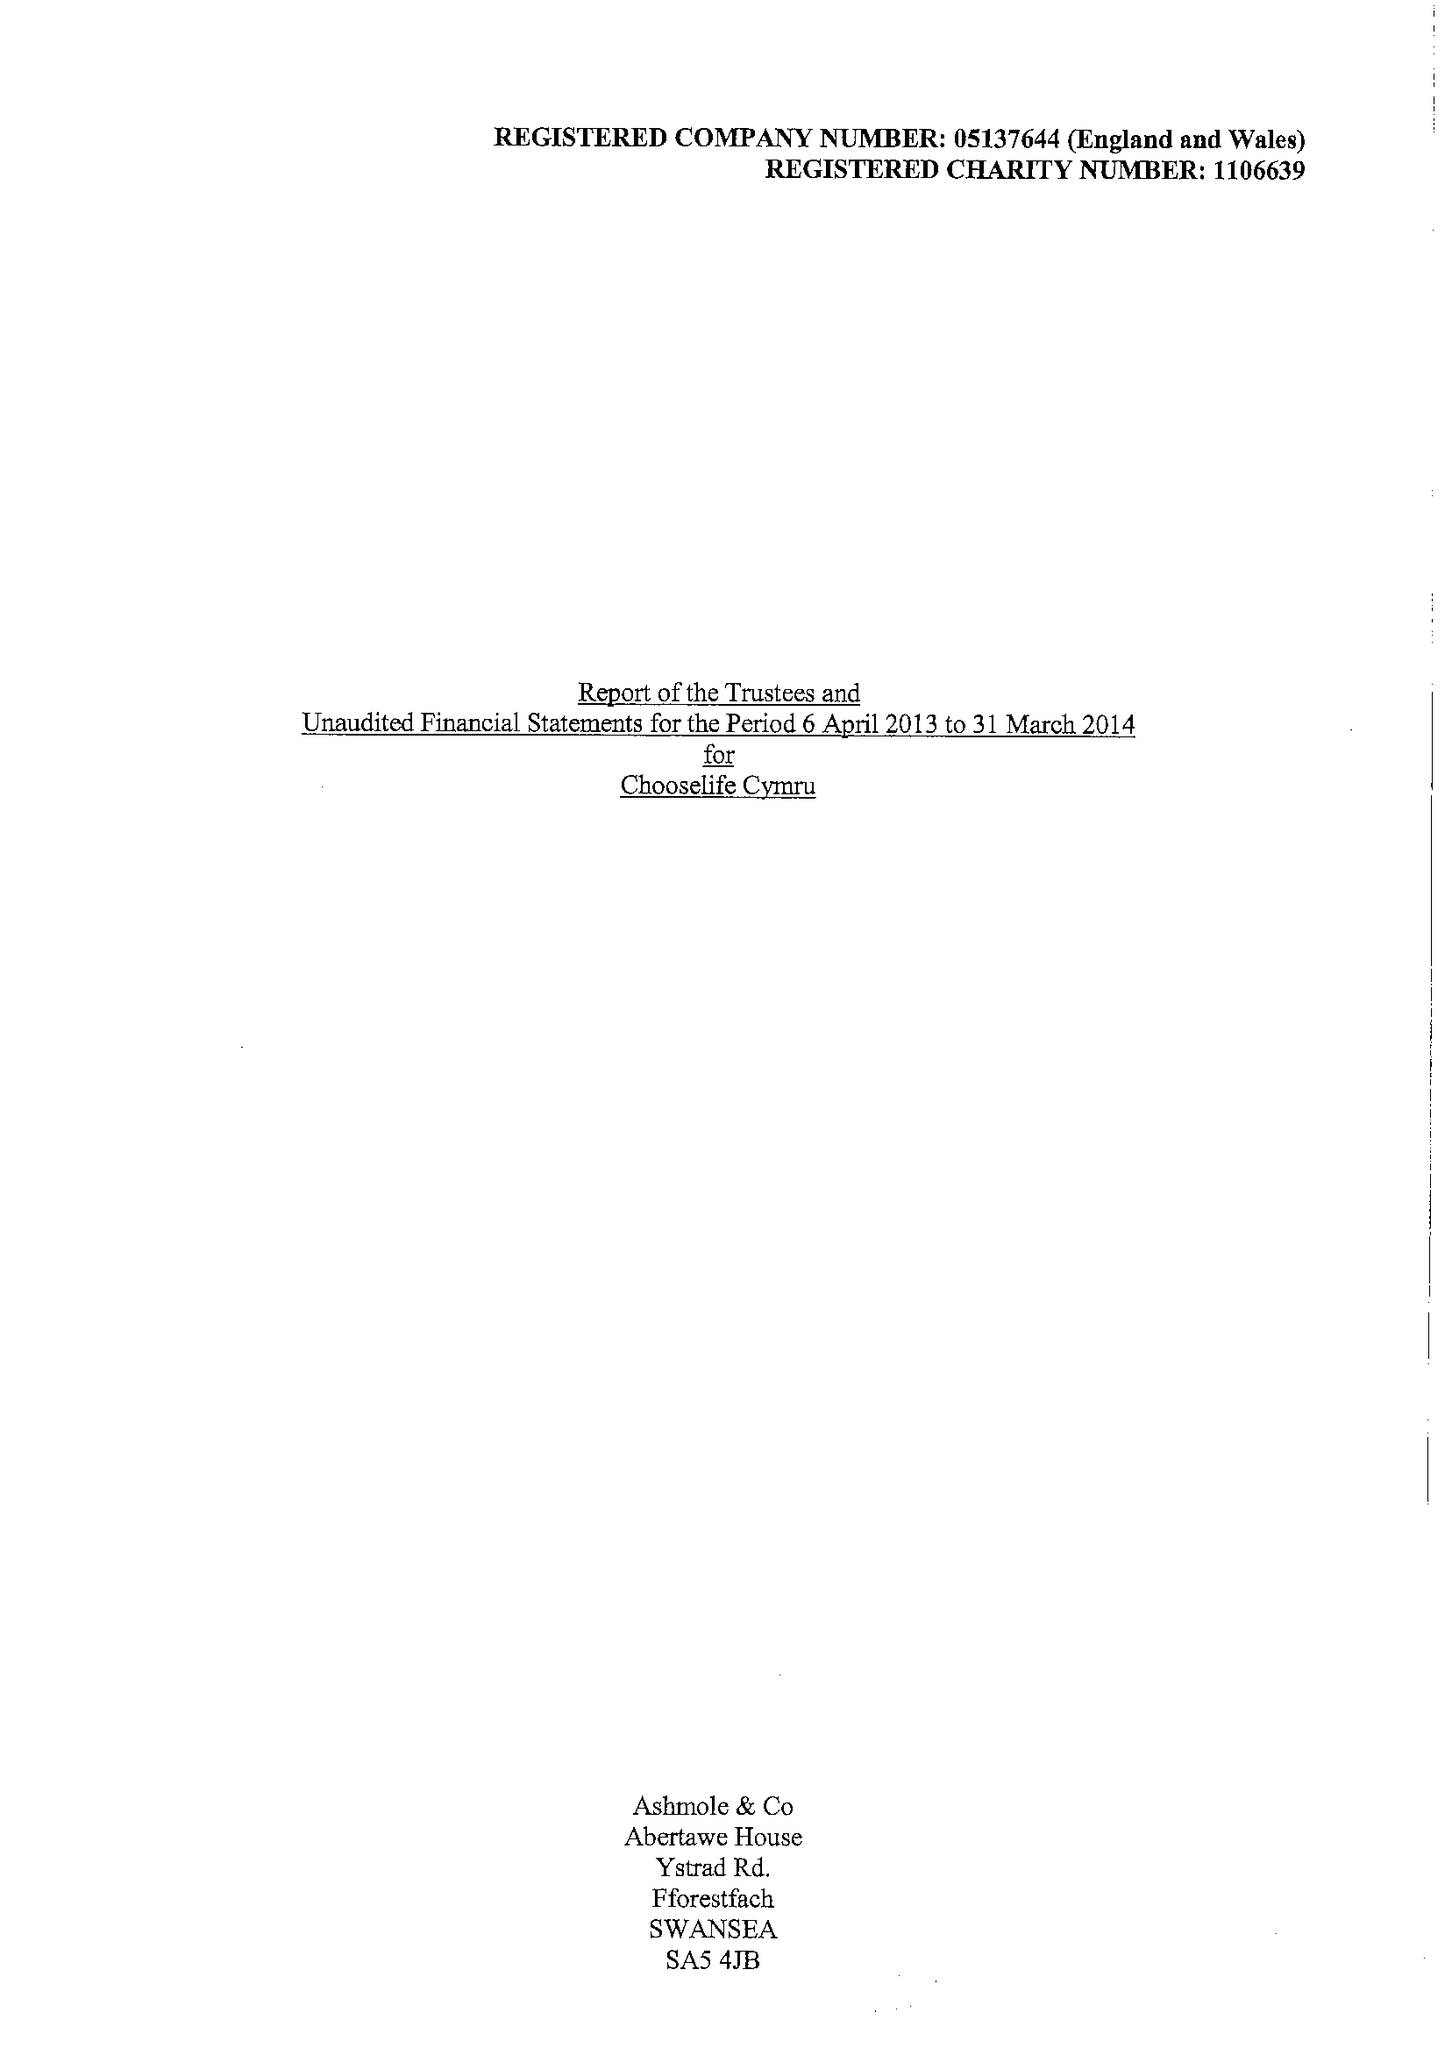What is the value for the address__post_town?
Answer the question using a single word or phrase. LLANELLI 